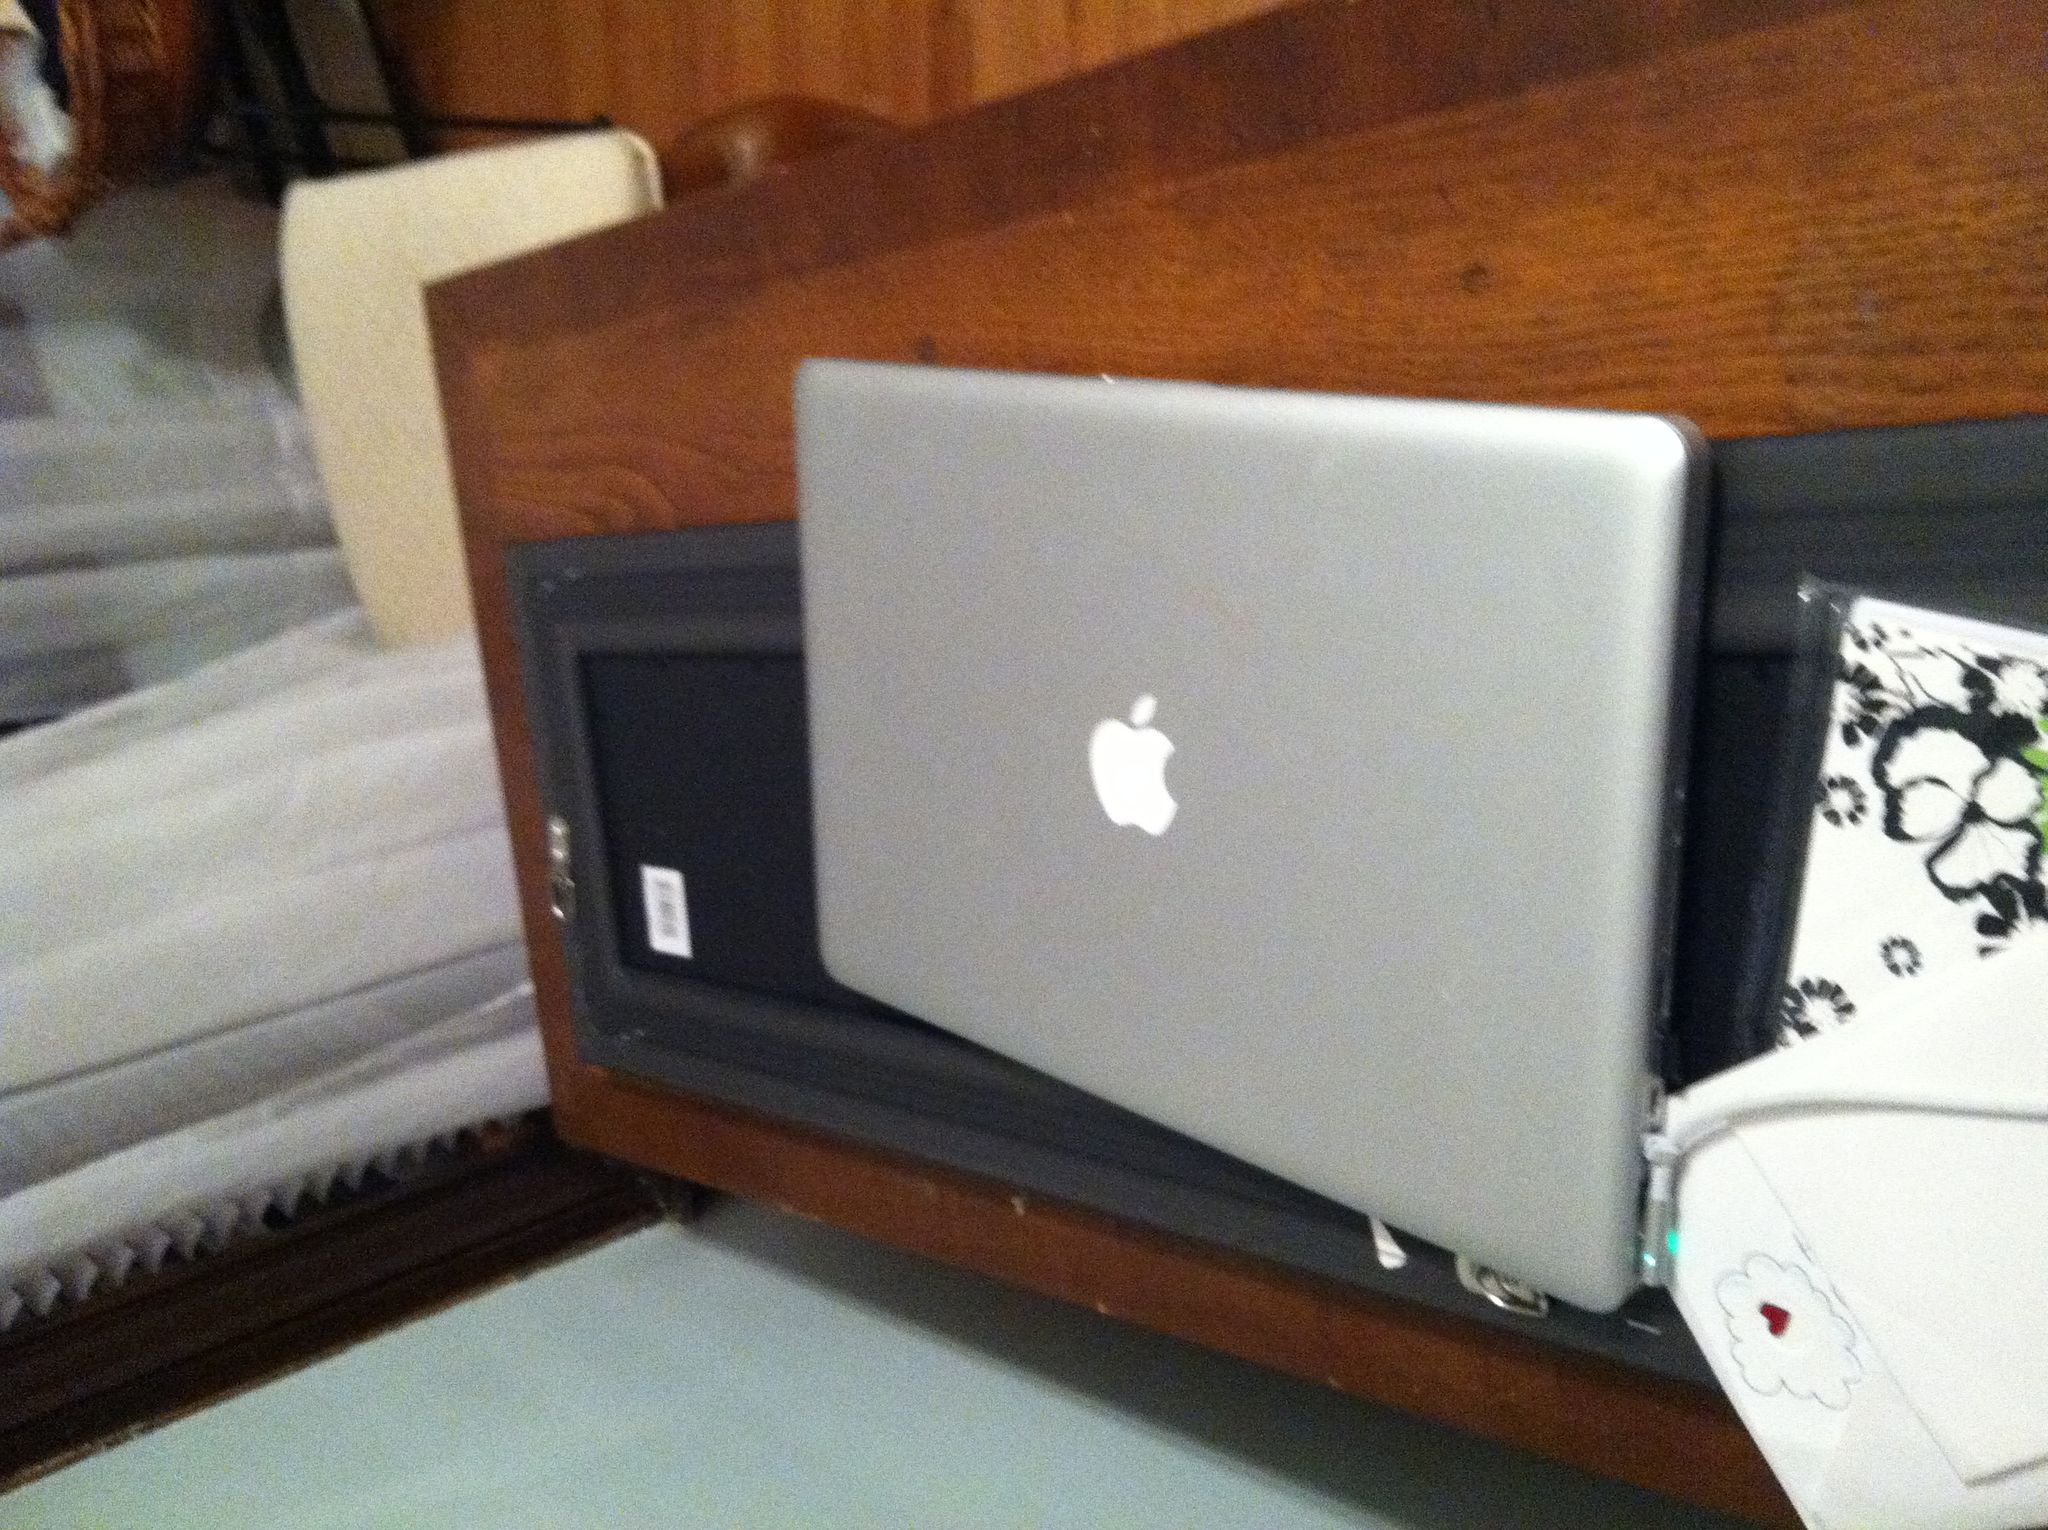What kind of machine is this, and who makes it? The machine in the image is an Apple iBook. The iBook line was distinct for its consumer-focused design with notable features such as its clamshell build. Apple Inc., one of the leading tech companies known for its innovative products, designed and manufactured it. 